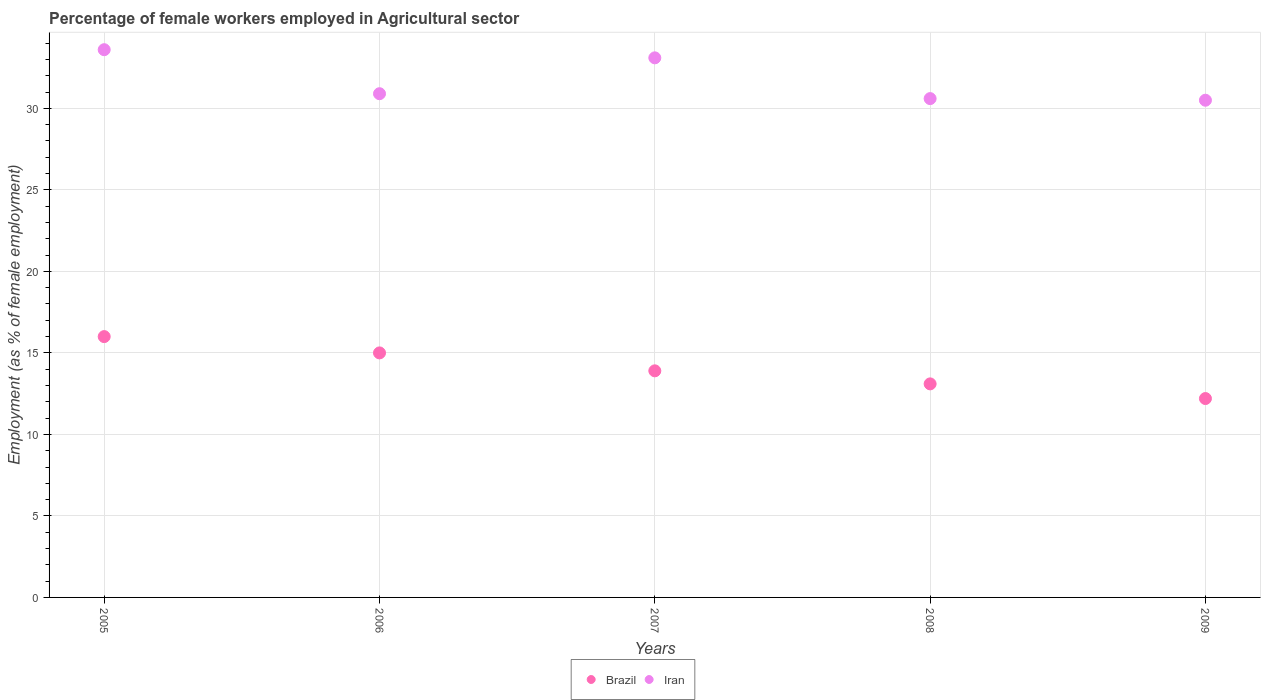Is the number of dotlines equal to the number of legend labels?
Your response must be concise. Yes. What is the percentage of females employed in Agricultural sector in Iran in 2007?
Give a very brief answer. 33.1. Across all years, what is the minimum percentage of females employed in Agricultural sector in Iran?
Provide a succinct answer. 30.5. In which year was the percentage of females employed in Agricultural sector in Iran maximum?
Make the answer very short. 2005. What is the total percentage of females employed in Agricultural sector in Iran in the graph?
Your answer should be compact. 158.7. What is the difference between the percentage of females employed in Agricultural sector in Iran in 2007 and that in 2008?
Provide a short and direct response. 2.5. What is the difference between the percentage of females employed in Agricultural sector in Brazil in 2006 and the percentage of females employed in Agricultural sector in Iran in 2009?
Provide a succinct answer. -15.5. What is the average percentage of females employed in Agricultural sector in Iran per year?
Your answer should be very brief. 31.74. In the year 2005, what is the difference between the percentage of females employed in Agricultural sector in Brazil and percentage of females employed in Agricultural sector in Iran?
Offer a very short reply. -17.6. In how many years, is the percentage of females employed in Agricultural sector in Brazil greater than 10 %?
Give a very brief answer. 5. What is the ratio of the percentage of females employed in Agricultural sector in Iran in 2005 to that in 2007?
Provide a succinct answer. 1.02. What is the difference between the highest and the second highest percentage of females employed in Agricultural sector in Brazil?
Offer a terse response. 1. What is the difference between the highest and the lowest percentage of females employed in Agricultural sector in Brazil?
Give a very brief answer. 3.8. Are the values on the major ticks of Y-axis written in scientific E-notation?
Your answer should be very brief. No. Does the graph contain any zero values?
Offer a very short reply. No. Where does the legend appear in the graph?
Offer a very short reply. Bottom center. What is the title of the graph?
Offer a terse response. Percentage of female workers employed in Agricultural sector. Does "Turks and Caicos Islands" appear as one of the legend labels in the graph?
Your answer should be very brief. No. What is the label or title of the X-axis?
Provide a short and direct response. Years. What is the label or title of the Y-axis?
Provide a short and direct response. Employment (as % of female employment). What is the Employment (as % of female employment) in Iran in 2005?
Ensure brevity in your answer.  33.6. What is the Employment (as % of female employment) of Iran in 2006?
Make the answer very short. 30.9. What is the Employment (as % of female employment) of Brazil in 2007?
Your answer should be very brief. 13.9. What is the Employment (as % of female employment) in Iran in 2007?
Keep it short and to the point. 33.1. What is the Employment (as % of female employment) of Brazil in 2008?
Keep it short and to the point. 13.1. What is the Employment (as % of female employment) of Iran in 2008?
Give a very brief answer. 30.6. What is the Employment (as % of female employment) in Brazil in 2009?
Ensure brevity in your answer.  12.2. What is the Employment (as % of female employment) in Iran in 2009?
Give a very brief answer. 30.5. Across all years, what is the maximum Employment (as % of female employment) of Brazil?
Ensure brevity in your answer.  16. Across all years, what is the maximum Employment (as % of female employment) of Iran?
Make the answer very short. 33.6. Across all years, what is the minimum Employment (as % of female employment) in Brazil?
Offer a very short reply. 12.2. Across all years, what is the minimum Employment (as % of female employment) in Iran?
Offer a very short reply. 30.5. What is the total Employment (as % of female employment) of Brazil in the graph?
Your answer should be very brief. 70.2. What is the total Employment (as % of female employment) in Iran in the graph?
Offer a very short reply. 158.7. What is the difference between the Employment (as % of female employment) in Brazil in 2005 and that in 2007?
Make the answer very short. 2.1. What is the difference between the Employment (as % of female employment) of Iran in 2005 and that in 2007?
Make the answer very short. 0.5. What is the difference between the Employment (as % of female employment) of Brazil in 2005 and that in 2009?
Ensure brevity in your answer.  3.8. What is the difference between the Employment (as % of female employment) in Iran in 2005 and that in 2009?
Give a very brief answer. 3.1. What is the difference between the Employment (as % of female employment) of Brazil in 2006 and that in 2007?
Your answer should be very brief. 1.1. What is the difference between the Employment (as % of female employment) of Brazil in 2006 and that in 2009?
Your answer should be compact. 2.8. What is the difference between the Employment (as % of female employment) in Brazil in 2007 and that in 2008?
Your response must be concise. 0.8. What is the difference between the Employment (as % of female employment) in Brazil in 2008 and that in 2009?
Provide a short and direct response. 0.9. What is the difference between the Employment (as % of female employment) in Brazil in 2005 and the Employment (as % of female employment) in Iran in 2006?
Provide a succinct answer. -14.9. What is the difference between the Employment (as % of female employment) in Brazil in 2005 and the Employment (as % of female employment) in Iran in 2007?
Make the answer very short. -17.1. What is the difference between the Employment (as % of female employment) in Brazil in 2005 and the Employment (as % of female employment) in Iran in 2008?
Provide a short and direct response. -14.6. What is the difference between the Employment (as % of female employment) of Brazil in 2006 and the Employment (as % of female employment) of Iran in 2007?
Offer a terse response. -18.1. What is the difference between the Employment (as % of female employment) in Brazil in 2006 and the Employment (as % of female employment) in Iran in 2008?
Ensure brevity in your answer.  -15.6. What is the difference between the Employment (as % of female employment) of Brazil in 2006 and the Employment (as % of female employment) of Iran in 2009?
Provide a succinct answer. -15.5. What is the difference between the Employment (as % of female employment) in Brazil in 2007 and the Employment (as % of female employment) in Iran in 2008?
Offer a very short reply. -16.7. What is the difference between the Employment (as % of female employment) of Brazil in 2007 and the Employment (as % of female employment) of Iran in 2009?
Your response must be concise. -16.6. What is the difference between the Employment (as % of female employment) of Brazil in 2008 and the Employment (as % of female employment) of Iran in 2009?
Provide a short and direct response. -17.4. What is the average Employment (as % of female employment) in Brazil per year?
Your answer should be compact. 14.04. What is the average Employment (as % of female employment) of Iran per year?
Your answer should be very brief. 31.74. In the year 2005, what is the difference between the Employment (as % of female employment) of Brazil and Employment (as % of female employment) of Iran?
Give a very brief answer. -17.6. In the year 2006, what is the difference between the Employment (as % of female employment) in Brazil and Employment (as % of female employment) in Iran?
Give a very brief answer. -15.9. In the year 2007, what is the difference between the Employment (as % of female employment) in Brazil and Employment (as % of female employment) in Iran?
Ensure brevity in your answer.  -19.2. In the year 2008, what is the difference between the Employment (as % of female employment) of Brazil and Employment (as % of female employment) of Iran?
Your answer should be compact. -17.5. In the year 2009, what is the difference between the Employment (as % of female employment) of Brazil and Employment (as % of female employment) of Iran?
Provide a short and direct response. -18.3. What is the ratio of the Employment (as % of female employment) in Brazil in 2005 to that in 2006?
Offer a very short reply. 1.07. What is the ratio of the Employment (as % of female employment) in Iran in 2005 to that in 2006?
Offer a terse response. 1.09. What is the ratio of the Employment (as % of female employment) in Brazil in 2005 to that in 2007?
Provide a succinct answer. 1.15. What is the ratio of the Employment (as % of female employment) in Iran in 2005 to that in 2007?
Keep it short and to the point. 1.02. What is the ratio of the Employment (as % of female employment) of Brazil in 2005 to that in 2008?
Ensure brevity in your answer.  1.22. What is the ratio of the Employment (as % of female employment) of Iran in 2005 to that in 2008?
Your response must be concise. 1.1. What is the ratio of the Employment (as % of female employment) in Brazil in 2005 to that in 2009?
Give a very brief answer. 1.31. What is the ratio of the Employment (as % of female employment) of Iran in 2005 to that in 2009?
Provide a short and direct response. 1.1. What is the ratio of the Employment (as % of female employment) in Brazil in 2006 to that in 2007?
Keep it short and to the point. 1.08. What is the ratio of the Employment (as % of female employment) in Iran in 2006 to that in 2007?
Ensure brevity in your answer.  0.93. What is the ratio of the Employment (as % of female employment) in Brazil in 2006 to that in 2008?
Offer a very short reply. 1.15. What is the ratio of the Employment (as % of female employment) of Iran in 2006 to that in 2008?
Provide a short and direct response. 1.01. What is the ratio of the Employment (as % of female employment) of Brazil in 2006 to that in 2009?
Your response must be concise. 1.23. What is the ratio of the Employment (as % of female employment) of Iran in 2006 to that in 2009?
Keep it short and to the point. 1.01. What is the ratio of the Employment (as % of female employment) of Brazil in 2007 to that in 2008?
Your answer should be very brief. 1.06. What is the ratio of the Employment (as % of female employment) in Iran in 2007 to that in 2008?
Ensure brevity in your answer.  1.08. What is the ratio of the Employment (as % of female employment) in Brazil in 2007 to that in 2009?
Your answer should be very brief. 1.14. What is the ratio of the Employment (as % of female employment) of Iran in 2007 to that in 2009?
Make the answer very short. 1.09. What is the ratio of the Employment (as % of female employment) of Brazil in 2008 to that in 2009?
Your response must be concise. 1.07. What is the ratio of the Employment (as % of female employment) in Iran in 2008 to that in 2009?
Keep it short and to the point. 1. What is the difference between the highest and the lowest Employment (as % of female employment) in Iran?
Keep it short and to the point. 3.1. 